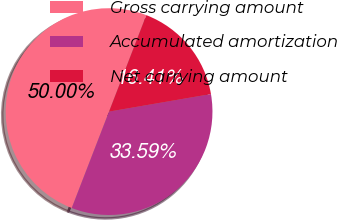Convert chart. <chart><loc_0><loc_0><loc_500><loc_500><pie_chart><fcel>Gross carrying amount<fcel>Accumulated amortization<fcel>Net carrying amount<nl><fcel>50.0%<fcel>33.59%<fcel>16.41%<nl></chart> 